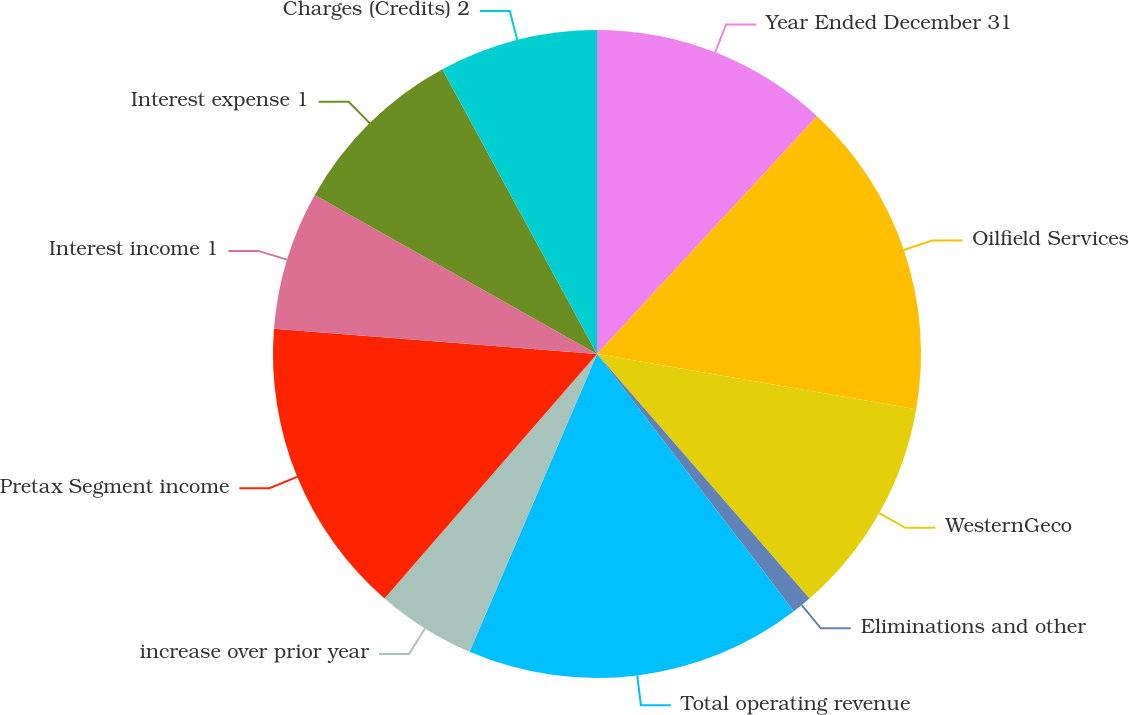<chart> <loc_0><loc_0><loc_500><loc_500><pie_chart><fcel>Year Ended December 31<fcel>Oilfield Services<fcel>WesternGeco<fcel>Eliminations and other<fcel>Total operating revenue<fcel>increase over prior year<fcel>Pretax Segment income<fcel>Interest income 1<fcel>Interest expense 1<fcel>Charges (Credits) 2<nl><fcel>11.88%<fcel>15.84%<fcel>10.89%<fcel>0.99%<fcel>16.83%<fcel>4.95%<fcel>14.85%<fcel>6.93%<fcel>8.91%<fcel>7.92%<nl></chart> 